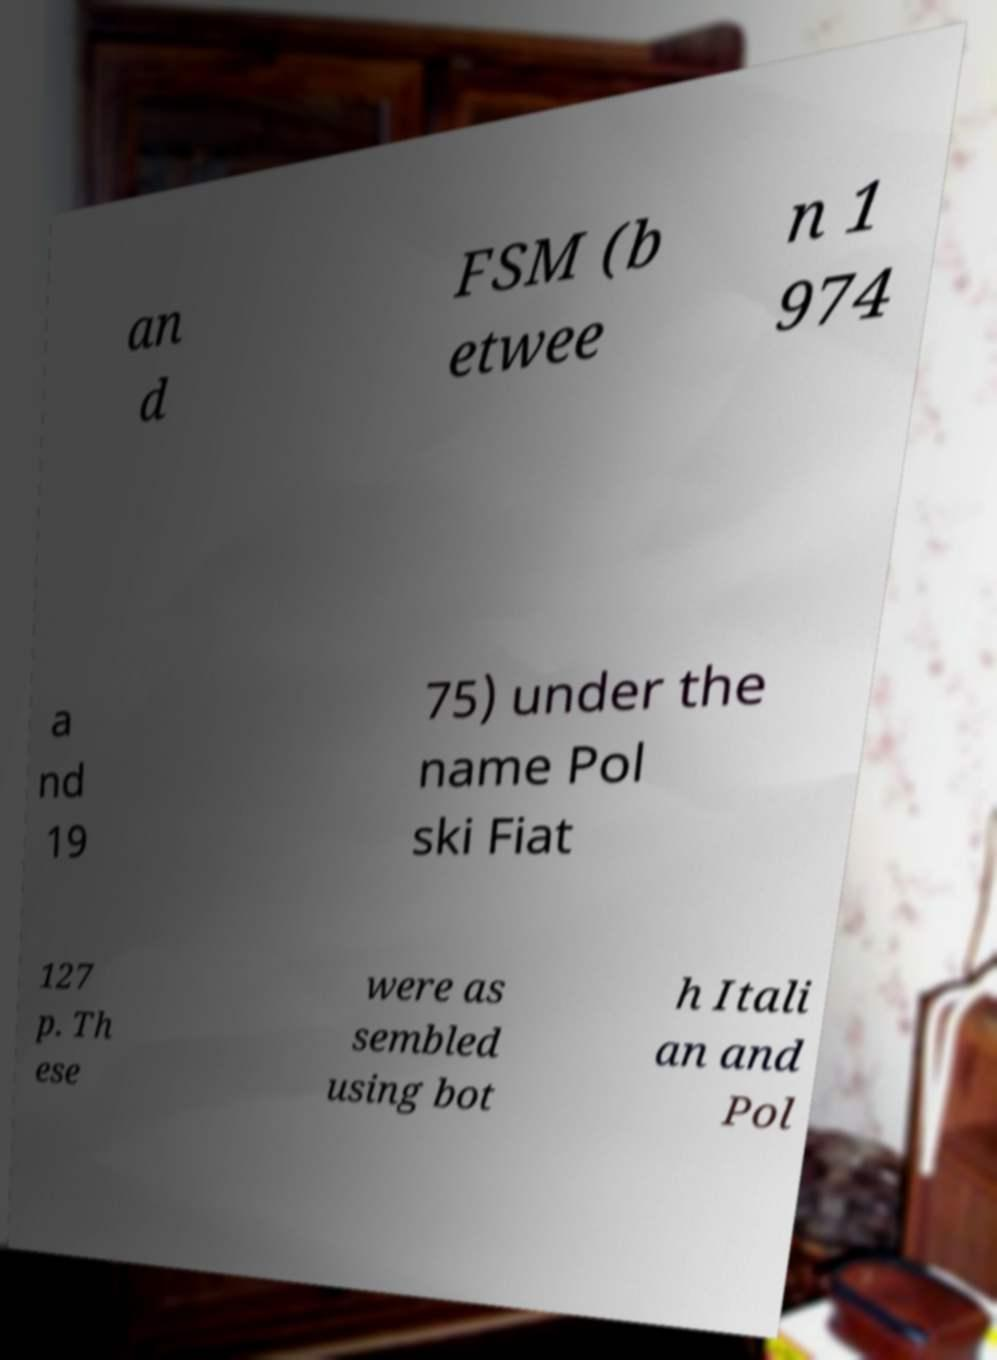Could you extract and type out the text from this image? an d FSM (b etwee n 1 974 a nd 19 75) under the name Pol ski Fiat 127 p. Th ese were as sembled using bot h Itali an and Pol 